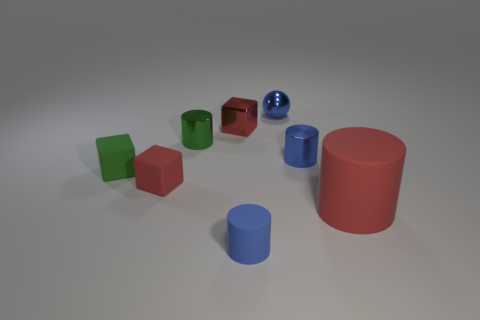Subtract all green cylinders. How many red cubes are left? 2 Subtract all red cubes. How many cubes are left? 1 Add 2 large rubber cylinders. How many objects exist? 10 Subtract all red cylinders. How many cylinders are left? 3 Subtract all blocks. How many objects are left? 5 Subtract 4 cylinders. How many cylinders are left? 0 Subtract all large yellow matte cylinders. Subtract all small metal cylinders. How many objects are left? 6 Add 4 big things. How many big things are left? 5 Add 4 large gray metallic cubes. How many large gray metallic cubes exist? 4 Subtract 0 cyan balls. How many objects are left? 8 